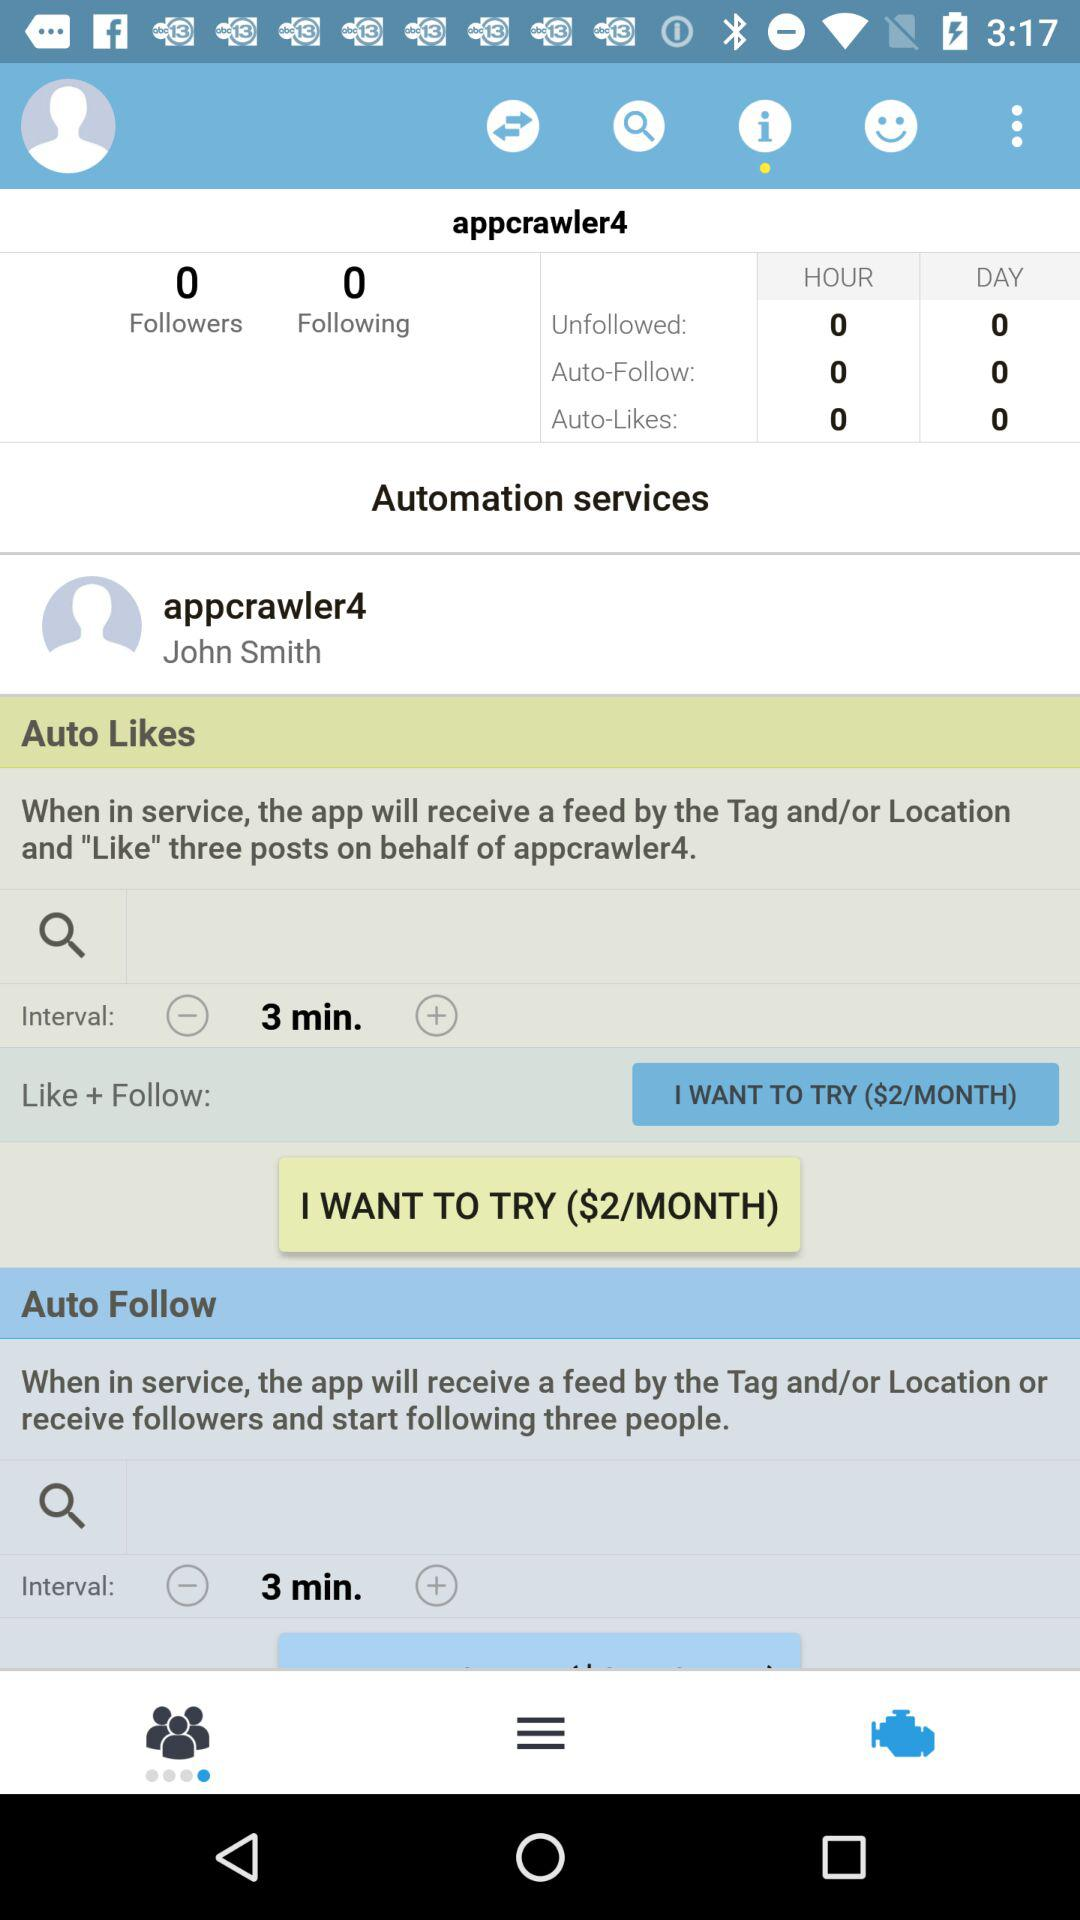What is the interval time? The interval time is 3 minutes. 